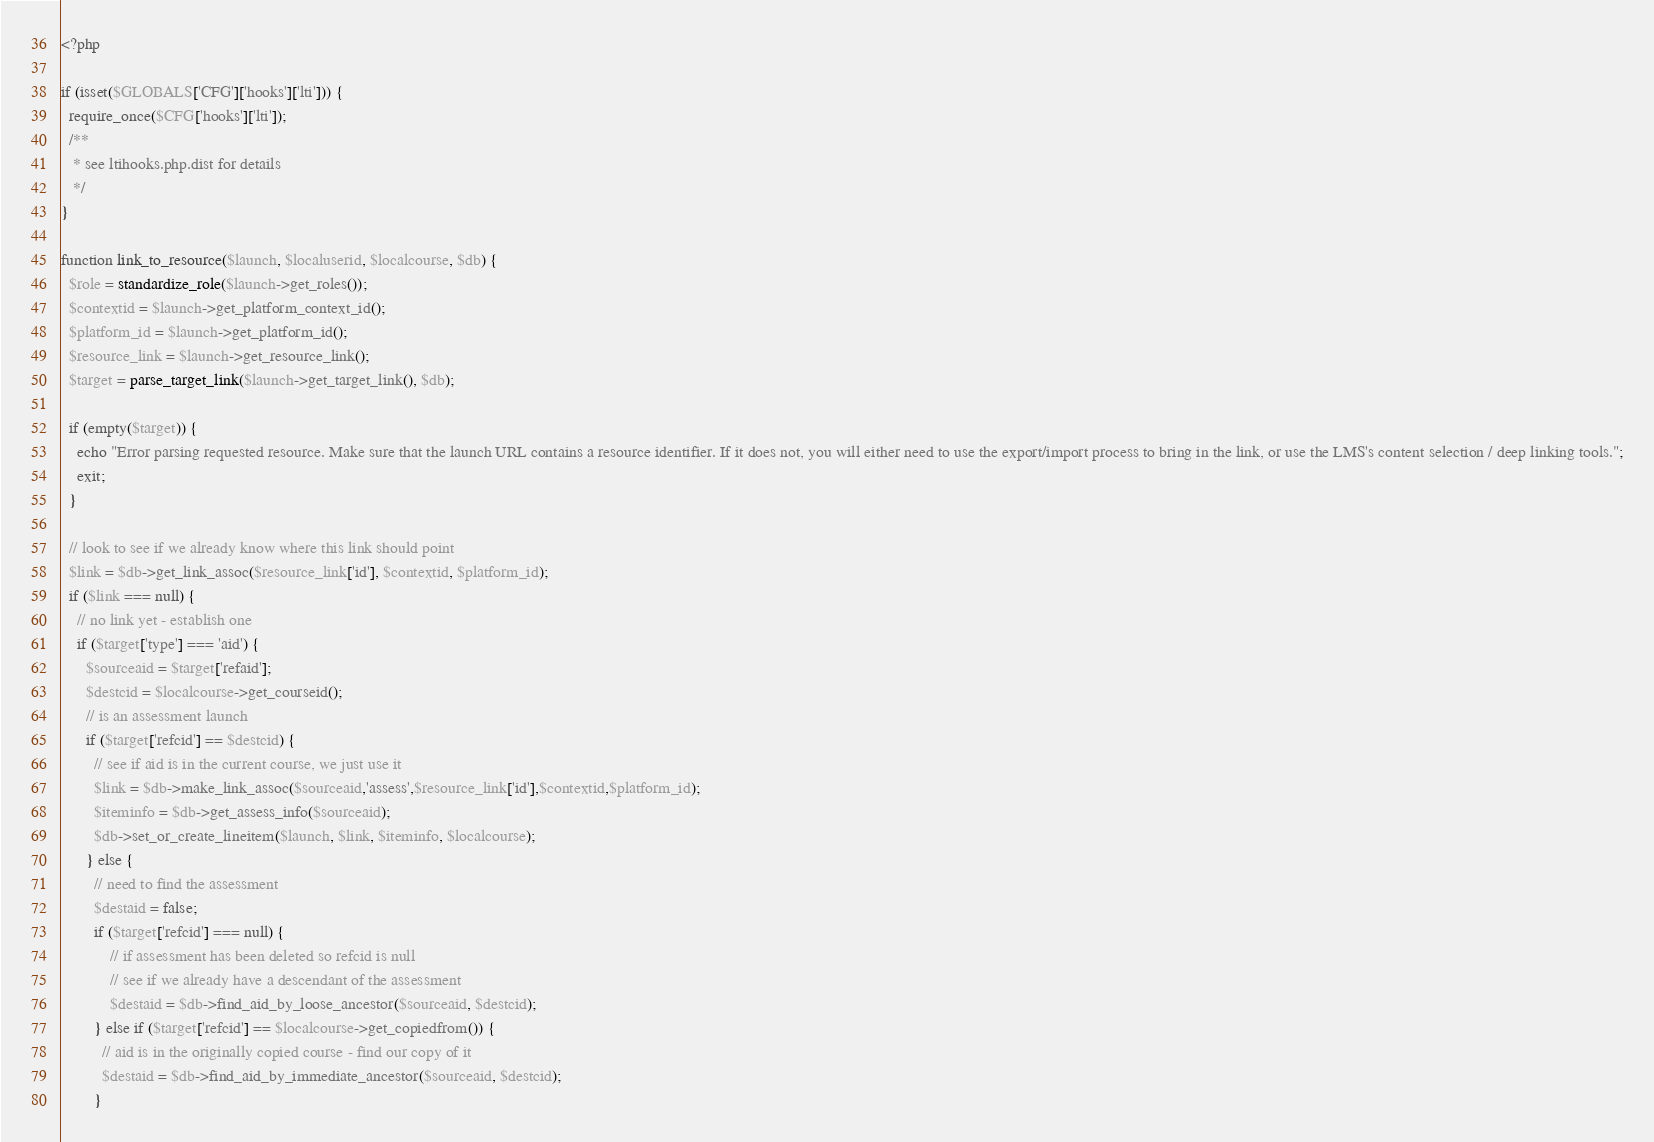Convert code to text. <code><loc_0><loc_0><loc_500><loc_500><_PHP_><?php

if (isset($GLOBALS['CFG']['hooks']['lti'])) {
  require_once($CFG['hooks']['lti']);
  /**
   * see ltihooks.php.dist for details
   */
}

function link_to_resource($launch, $localuserid, $localcourse, $db) {
  $role = standardize_role($launch->get_roles());
  $contextid = $launch->get_platform_context_id();
  $platform_id = $launch->get_platform_id();
  $resource_link = $launch->get_resource_link();
  $target = parse_target_link($launch->get_target_link(), $db);

  if (empty($target)) {
    echo "Error parsing requested resource. Make sure that the launch URL contains a resource identifier. If it does not, you will either need to use the export/import process to bring in the link, or use the LMS's content selection / deep linking tools.";
    exit;
  }

  // look to see if we already know where this link should point
  $link = $db->get_link_assoc($resource_link['id'], $contextid, $platform_id);
  if ($link === null) {
    // no link yet - establish one
    if ($target['type'] === 'aid') {
      $sourceaid = $target['refaid'];
      $destcid = $localcourse->get_courseid();
      // is an assessment launch
      if ($target['refcid'] == $destcid) {
        // see if aid is in the current course, we just use it
        $link = $db->make_link_assoc($sourceaid,'assess',$resource_link['id'],$contextid,$platform_id);
        $iteminfo = $db->get_assess_info($sourceaid);
        $db->set_or_create_lineitem($launch, $link, $iteminfo, $localcourse);
      } else {
        // need to find the assessment
        $destaid = false;
        if ($target['refcid'] === null) {
            // if assessment has been deleted so refcid is null
            // see if we already have a descendant of the assessment
            $destaid = $db->find_aid_by_loose_ancestor($sourceaid, $destcid);
        } else if ($target['refcid'] == $localcourse->get_copiedfrom()) {
          // aid is in the originally copied course - find our copy of it
          $destaid = $db->find_aid_by_immediate_ancestor($sourceaid, $destcid);
        }</code> 